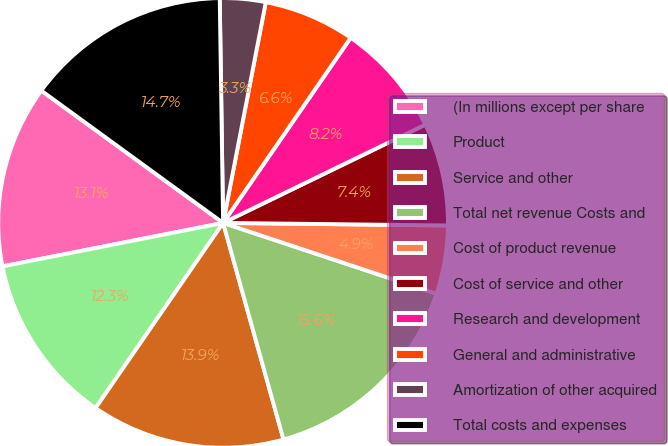Convert chart to OTSL. <chart><loc_0><loc_0><loc_500><loc_500><pie_chart><fcel>(In millions except per share<fcel>Product<fcel>Service and other<fcel>Total net revenue Costs and<fcel>Cost of product revenue<fcel>Cost of service and other<fcel>Research and development<fcel>General and administrative<fcel>Amortization of other acquired<fcel>Total costs and expenses<nl><fcel>13.11%<fcel>12.3%<fcel>13.93%<fcel>15.57%<fcel>4.92%<fcel>7.38%<fcel>8.2%<fcel>6.56%<fcel>3.28%<fcel>14.75%<nl></chart> 